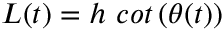<formula> <loc_0><loc_0><loc_500><loc_500>L ( t ) = h \ c o t \left ( \theta ( t ) \right )</formula> 